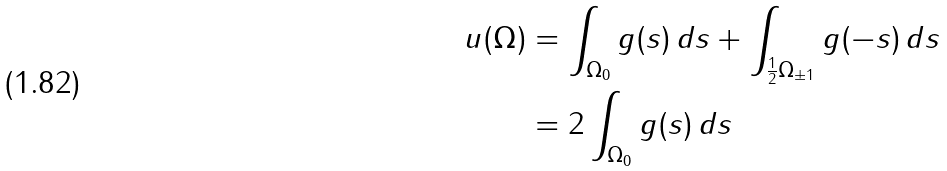Convert formula to latex. <formula><loc_0><loc_0><loc_500><loc_500>u ( \Omega ) & = \int _ { \Omega _ { 0 } } g ( s ) \, d s + \int _ { \frac { 1 } { 2 } \Omega _ { \pm 1 } } g ( - s ) \, d s \\ & = 2 \int _ { \Omega _ { 0 } } g ( s ) \, d s</formula> 